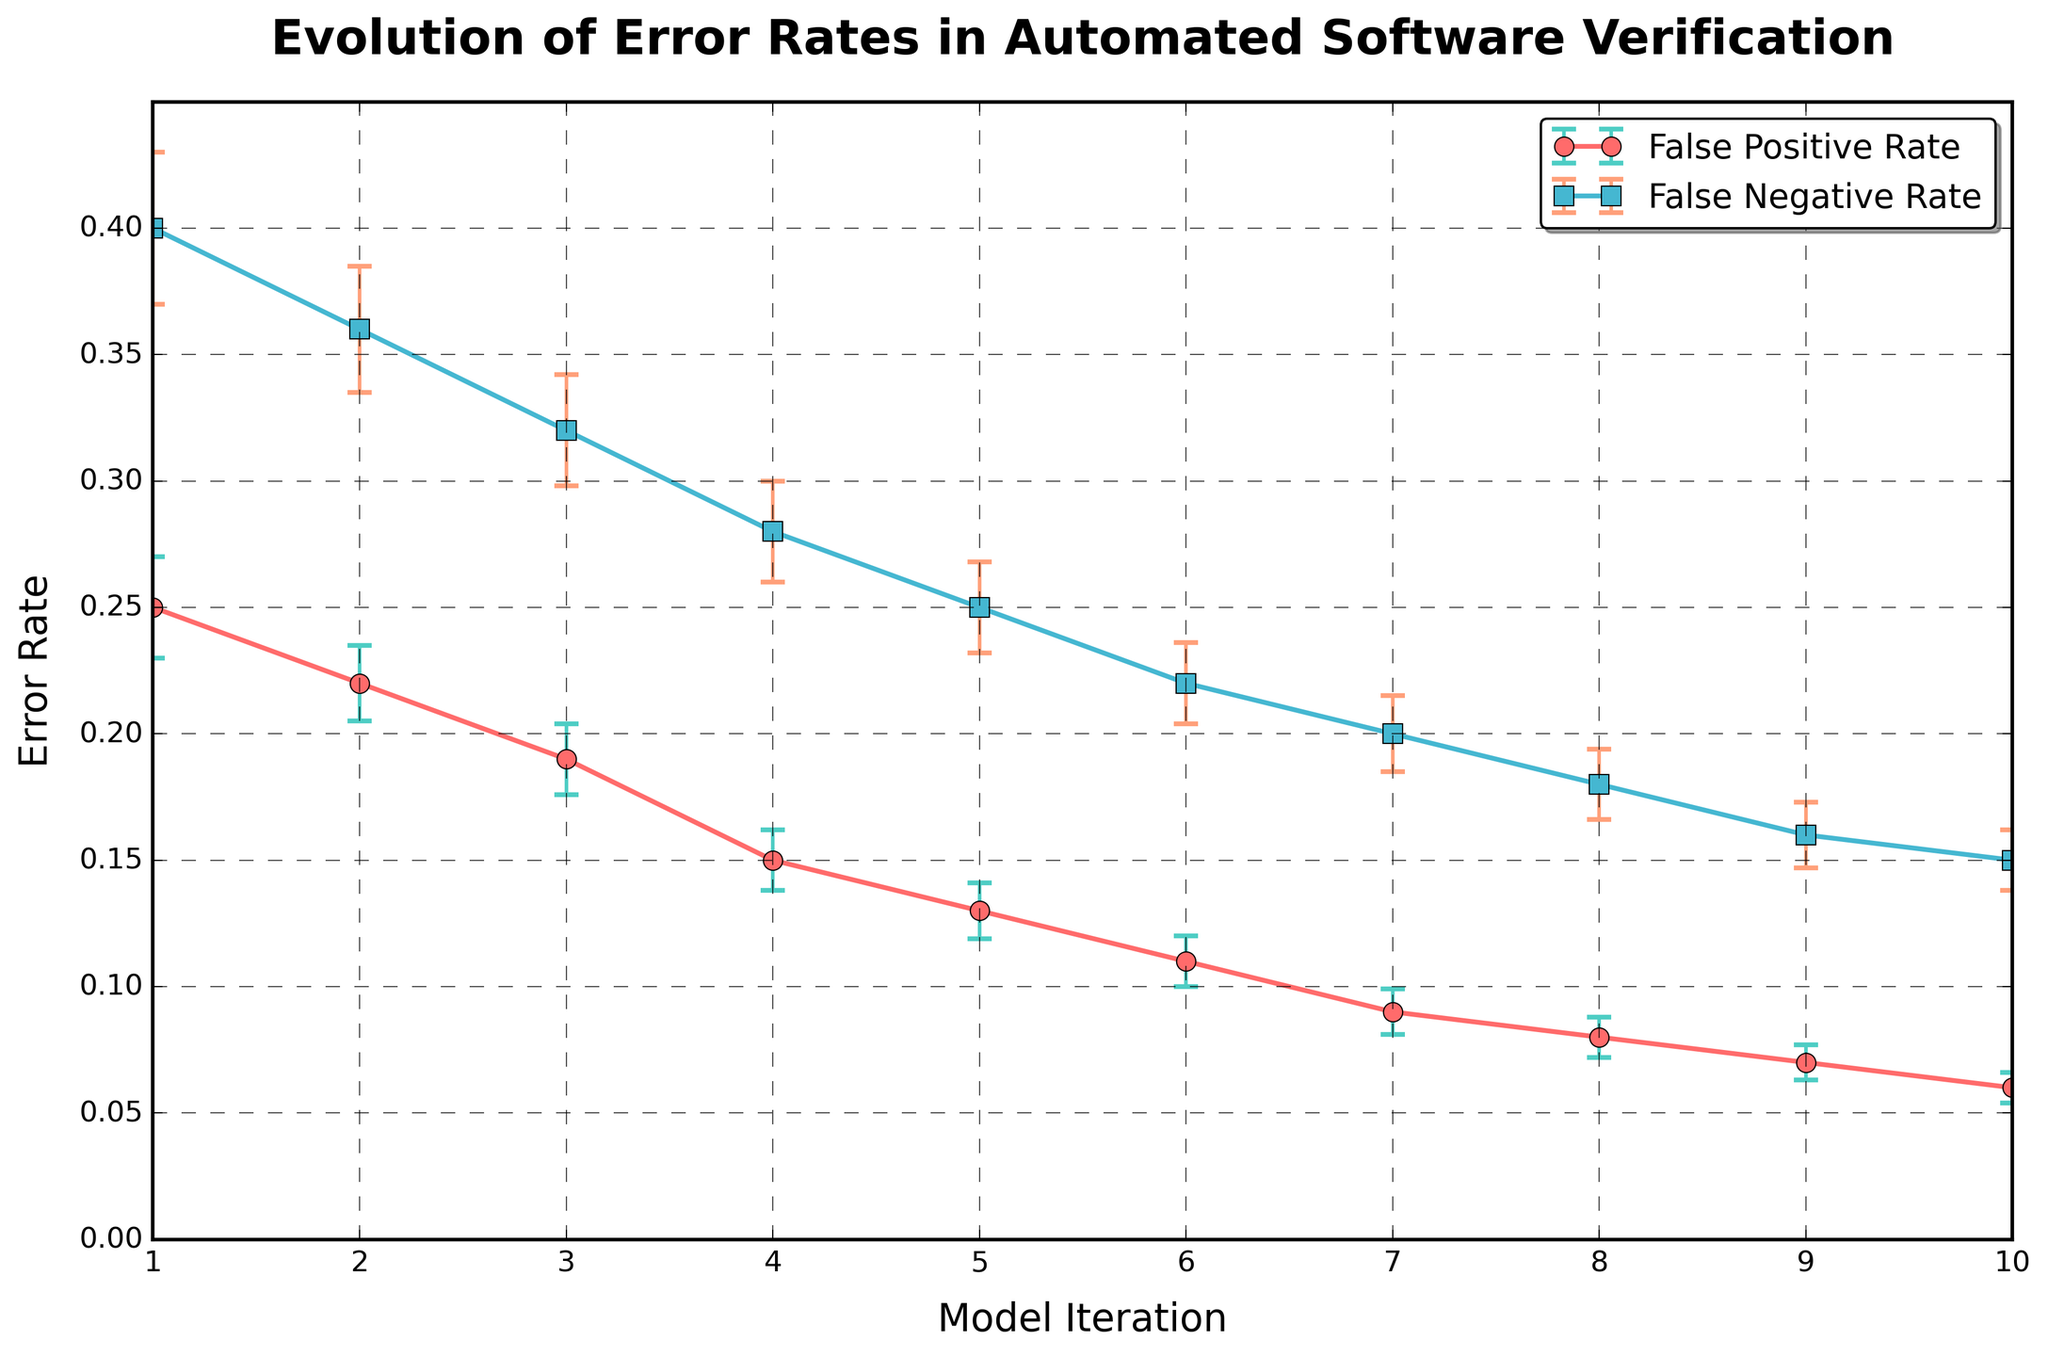What is the title of the figure? The title of the figure is located at the top of the chart. It is typically used to describe the main subject or the content of the chart. In this case, the title presented is "Evolution of Error Rates in Automated Software Verification".
Answer: Evolution of Error Rates in Automated Software Verification How does the false positive rate change over successive iterations? To determine the change in the false positive rate, look at the line associated with the false positive rate across the model iterations on the x-axis. The rate consistently decreases from 0.25 in iteration 1 to 0.06 in iteration 10.
Answer: It decreases Which iteration has the smallest false negative rate? To identify the iteration with the smallest false negative rate, trace the false negative rate values and locate the smallest one. From the graph, the smallest false negative rate is found at iteration 10 with a value of 0.15.
Answer: Iteration 10 What can you infer about the trend of error rates as the model iterations increase? By examining both the false positive and false negative rates as they are plotted over model iterations, it is noticeable that both error rates show a downward trend. This indicates that error rates are decreasing with successive model iterations.
Answer: Error rates are decreasing What is the error margin for the false negative rate at iteration 4? Locate iteration 4 on the x-axis and check the error bar for the false negative rate. The height of this error bar reflects the error margin, which is 0.02 as indicated in the data.
Answer: 0.02 Between which two consecutive iterations does the false positive rate show the largest decrease? To find the largest decrease, subtract the false positive rate of each iteration from the preceding one. The largest difference is between iteration 1 and iteration 2 where the rate drops from 0.25 to 0.22, which is a decrease of 0.03.
Answer: Between iteration 1 and 2 Compare the error margins of the false positive rate and the false negative rate at iteration 7. Which one is larger? At iteration 7, the error margin for the false positive rate is 0.009 and for the false negative rate is 0.015. Comparing these values, 0.015 is larger than 0.009.
Answer: False negative rate What is the average false positive rate across all iterations? To calculate the average, sum up all the false positive rates and divide by the number of iterations. The sum is 0.25 + 0.22 + 0.19 + 0.15 + 0.13 + 0.11 + 0.09 + 0.08 + 0.07 + 0.06 = 1.35. Dividing by 10 gives an average of 0.135.
Answer: 0.135 By how much did the false negative rate decrease from iteration 2 to iteration 8? Subtract the false negative rate at iteration 8 from the rate at iteration 2. The false negative rate at iteration 2 is 0.36 and at iteration 8 is 0.18. The decrease is 0.36 - 0.18 = 0.18.
Answer: 0.18 